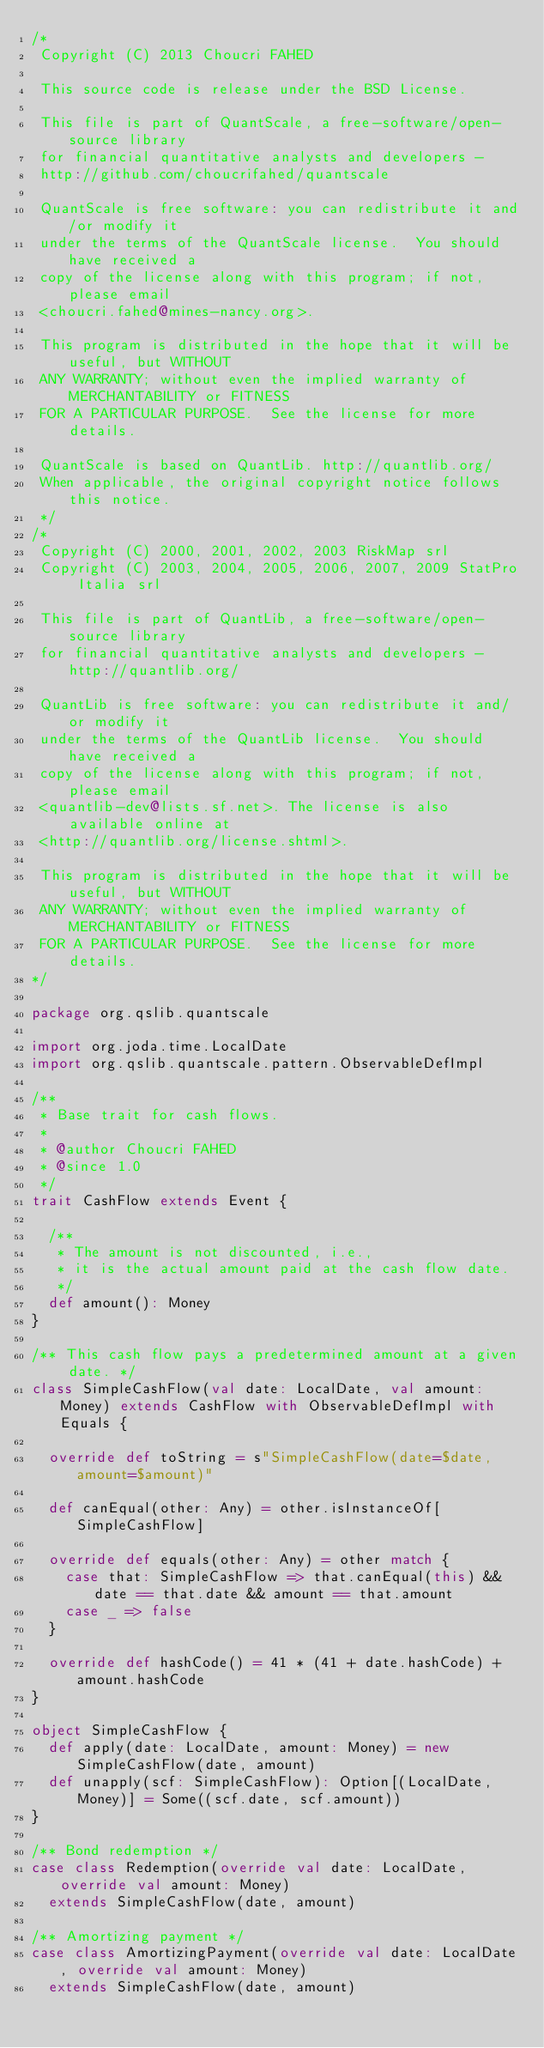Convert code to text. <code><loc_0><loc_0><loc_500><loc_500><_Scala_>/*
 Copyright (C) 2013 Choucri FAHED

 This source code is release under the BSD License.

 This file is part of QuantScale, a free-software/open-source library
 for financial quantitative analysts and developers - 
 http://github.com/choucrifahed/quantscale

 QuantScale is free software: you can redistribute it and/or modify it
 under the terms of the QuantScale license.  You should have received a
 copy of the license along with this program; if not, please email
 <choucri.fahed@mines-nancy.org>.

 This program is distributed in the hope that it will be useful, but WITHOUT
 ANY WARRANTY; without even the implied warranty of MERCHANTABILITY or FITNESS
 FOR A PARTICULAR PURPOSE.  See the license for more details.

 QuantScale is based on QuantLib. http://quantlib.org/
 When applicable, the original copyright notice follows this notice.
 */
/*
 Copyright (C) 2000, 2001, 2002, 2003 RiskMap srl
 Copyright (C) 2003, 2004, 2005, 2006, 2007, 2009 StatPro Italia srl

 This file is part of QuantLib, a free-software/open-source library
 for financial quantitative analysts and developers - http://quantlib.org/

 QuantLib is free software: you can redistribute it and/or modify it
 under the terms of the QuantLib license.  You should have received a
 copy of the license along with this program; if not, please email
 <quantlib-dev@lists.sf.net>. The license is also available online at
 <http://quantlib.org/license.shtml>.

 This program is distributed in the hope that it will be useful, but WITHOUT
 ANY WARRANTY; without even the implied warranty of MERCHANTABILITY or FITNESS
 FOR A PARTICULAR PURPOSE.  See the license for more details.
*/

package org.qslib.quantscale

import org.joda.time.LocalDate
import org.qslib.quantscale.pattern.ObservableDefImpl

/**
 * Base trait for cash flows.
 *
 * @author Choucri FAHED
 * @since 1.0
 */
trait CashFlow extends Event {

  /**
   * The amount is not discounted, i.e.,
   * it is the actual amount paid at the cash flow date.
   */
  def amount(): Money
}

/** This cash flow pays a predetermined amount at a given date. */
class SimpleCashFlow(val date: LocalDate, val amount: Money) extends CashFlow with ObservableDefImpl with Equals {

  override def toString = s"SimpleCashFlow(date=$date, amount=$amount)"

  def canEqual(other: Any) = other.isInstanceOf[SimpleCashFlow]

  override def equals(other: Any) = other match {
    case that: SimpleCashFlow => that.canEqual(this) && date == that.date && amount == that.amount
    case _ => false
  }

  override def hashCode() = 41 * (41 + date.hashCode) + amount.hashCode
}

object SimpleCashFlow {
  def apply(date: LocalDate, amount: Money) = new SimpleCashFlow(date, amount)
  def unapply(scf: SimpleCashFlow): Option[(LocalDate, Money)] = Some((scf.date, scf.amount))
}

/** Bond redemption */
case class Redemption(override val date: LocalDate, override val amount: Money)
  extends SimpleCashFlow(date, amount)

/** Amortizing payment */
case class AmortizingPayment(override val date: LocalDate, override val amount: Money)
  extends SimpleCashFlow(date, amount)
</code> 